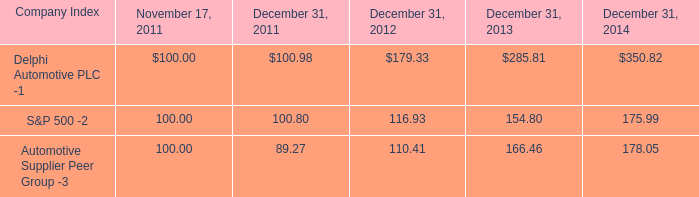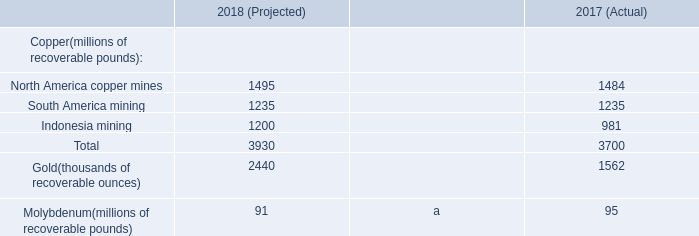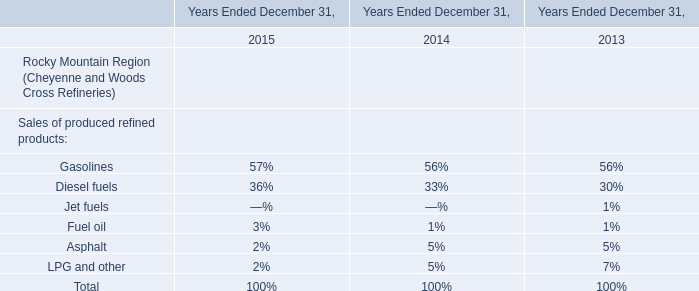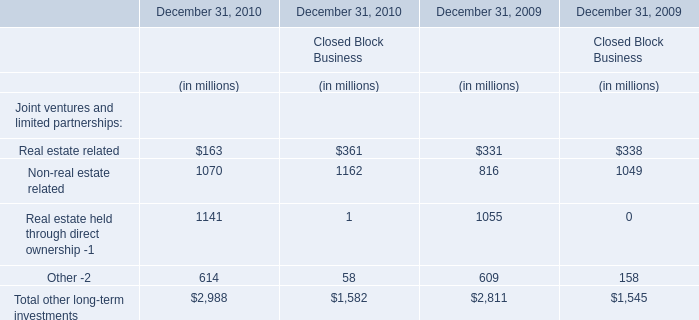What is the difference between 2009 and 2010 for Financial Services Businesses's highest Real estate related? 
Computations: (331 - 163)
Answer: 168.0. 